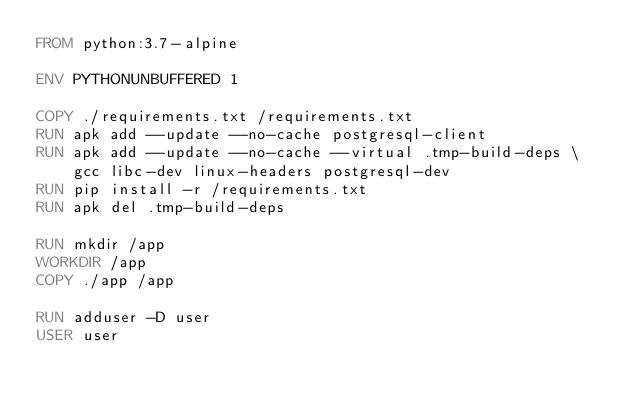<code> <loc_0><loc_0><loc_500><loc_500><_Dockerfile_>FROM python:3.7-alpine

ENV PYTHONUNBUFFERED 1

COPY ./requirements.txt /requirements.txt
RUN apk add --update --no-cache postgresql-client
RUN apk add --update --no-cache --virtual .tmp-build-deps \
    gcc libc-dev linux-headers postgresql-dev
RUN pip install -r /requirements.txt
RUN apk del .tmp-build-deps

RUN mkdir /app
WORKDIR /app
COPY ./app /app

RUN adduser -D user
USER user</code> 